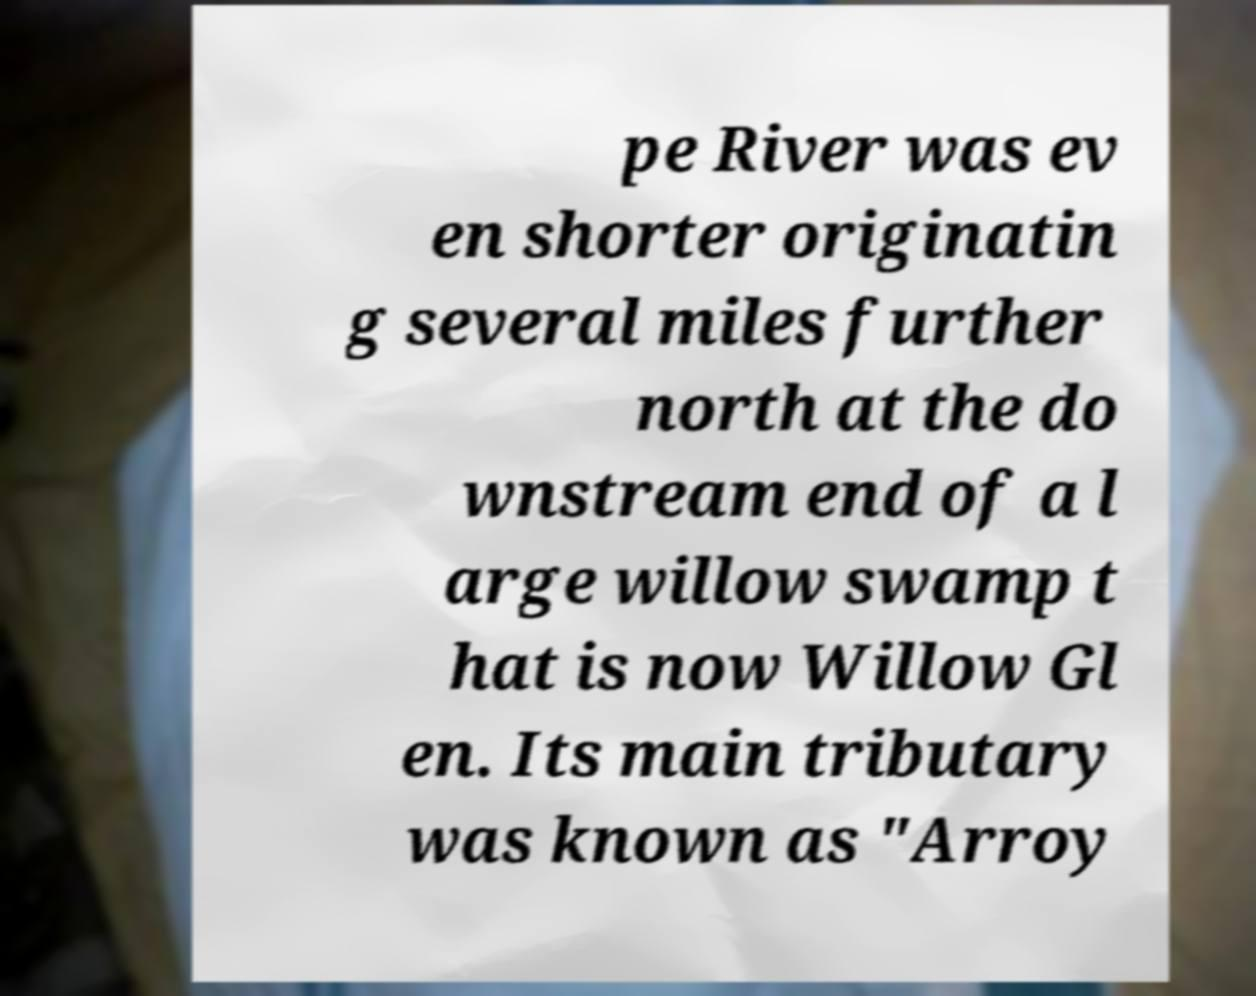Could you assist in decoding the text presented in this image and type it out clearly? pe River was ev en shorter originatin g several miles further north at the do wnstream end of a l arge willow swamp t hat is now Willow Gl en. Its main tributary was known as "Arroy 